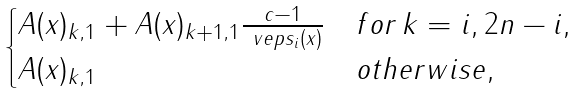Convert formula to latex. <formula><loc_0><loc_0><loc_500><loc_500>\begin{cases} A ( x ) _ { k , 1 } + A ( x ) _ { k + 1 , 1 } \frac { c - 1 } { \ v e p s _ { i } ( x ) } & f o r \, k = i , 2 n - i , \\ A ( x ) _ { k , 1 } & o t h e r w i s e , \end{cases}</formula> 